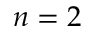Convert formula to latex. <formula><loc_0><loc_0><loc_500><loc_500>n = 2</formula> 